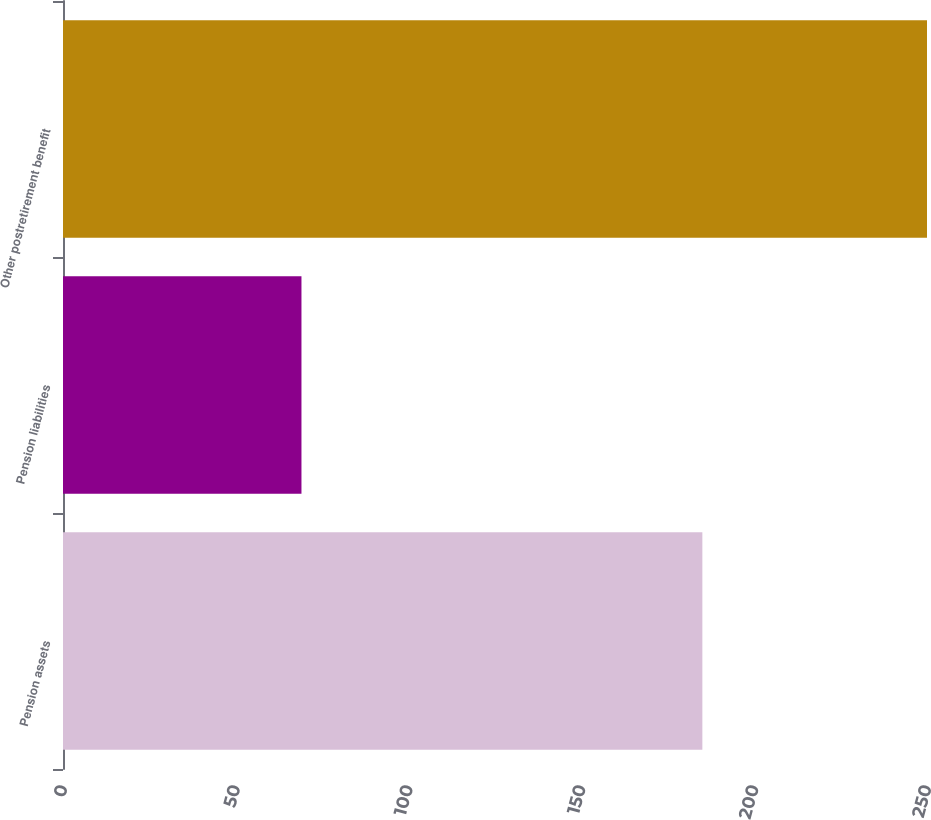<chart> <loc_0><loc_0><loc_500><loc_500><bar_chart><fcel>Pension assets<fcel>Pension liabilities<fcel>Other postretirement benefit<nl><fcel>185<fcel>69<fcel>250<nl></chart> 